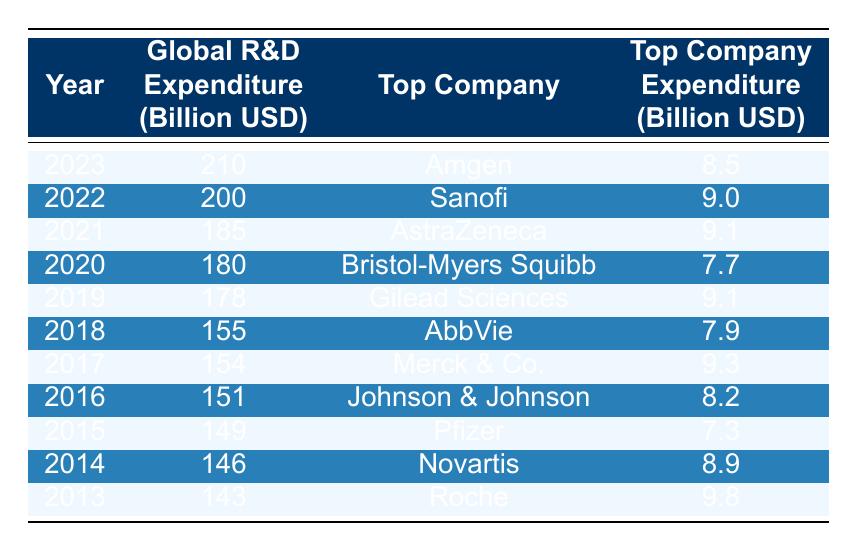What was the global pharmaceutical R&D expenditure in 2018? The table shows the global expenditure for each year. For 2018, the value listed is 155 billion USD.
Answer: 155 billion USD Which company had the highest expenditure in 2013? In the year 2013, the table indicates that the top company was Roche, with an expenditure of 9.8 billion USD.
Answer: Roche What was the average global R&D expenditure from 2013 to 2023? To find the average, sum the global expenditures from each year: 143 + 146 + 149 + 151 + 154 + 155 + 178 + 180 + 185 + 200 + 210 = 1,797. Then, divide this by the number of years (11), which gives 1,797 / 11 = 163.36.
Answer: 163.36 billion USD Did Gilead Sciences have the highest expenditure in 2019? The table lists Gilead Sciences as the top company for 2019, with an expenditure of 9.1 billion USD. However, we need to compare it with other years to confirm if it was the highest that year. There is no higher value listed for that year, confirming it is indeed the top expenditure.
Answer: Yes What was the difference in global R&D expenditure between 2020 and 2022? From the table, the global expenditure in 2020 is 180 billion USD and in 2022 is 200 billion USD. The difference is calculated as 200 - 180 = 20 billion USD.
Answer: 20 billion USD Which year saw the greatest increase in R&D expenditure from the previous year? To determine this, calculate the difference in global expenditures for each consecutive year: 2014-2013 (3), 2015-2014 (3), 2016-2015 (2), 2017-2016 (3), 2018-2017 (1), 2019-2018 (23), 2020-2019 (2), 2021-2020 (5), 2022-2021 (15), 2023-2022 (10). The largest increase is from 2018 to 2019, which is 23 billion USD.
Answer: 2018 to 2019 What was the expenditure of the top company in 2021 compared to 2013? For 2021, the top company's expenditure is 9.1 billion USD (AstraZeneca), and for 2013, it is 9.8 billion USD (Roche). The difference is 9.8 - 9.1 = 0.7 billion USD, meaning there was a decrease in the amount spent by the top company from 2013 to 2021.
Answer: Decrease by 0.7 billion USD Was the global pharmaceutical R&D expenditure higher in 2023 than in 2019? The table indicates that in 2023, the expenditure was 210 billion USD, while in 2019, it was 178 billion USD. Since 210 is greater than 178, it confirms that the expenditure is indeed higher in 2023.
Answer: Yes 